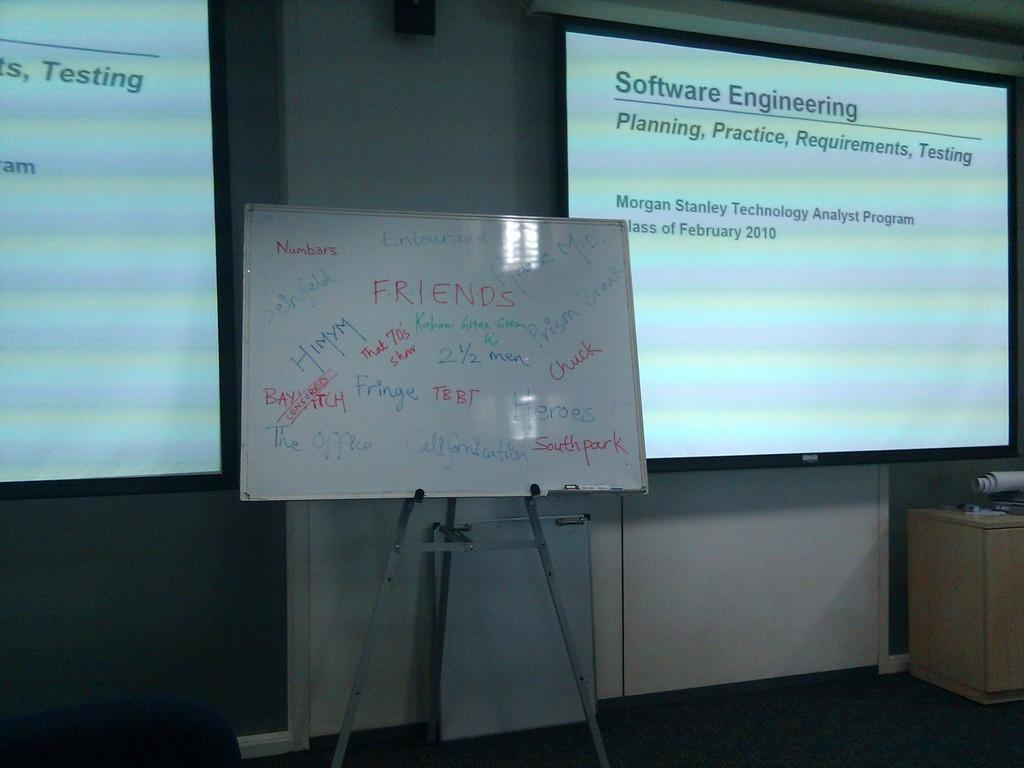What kind of engineering is being featured on the projection screen on the right side of the picture?
Your answer should be very brief. Software. What does the words say in green under "software engineering"?
Your answer should be compact. Planning, practice, requirements, testing. 